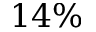<formula> <loc_0><loc_0><loc_500><loc_500>1 4 \%</formula> 